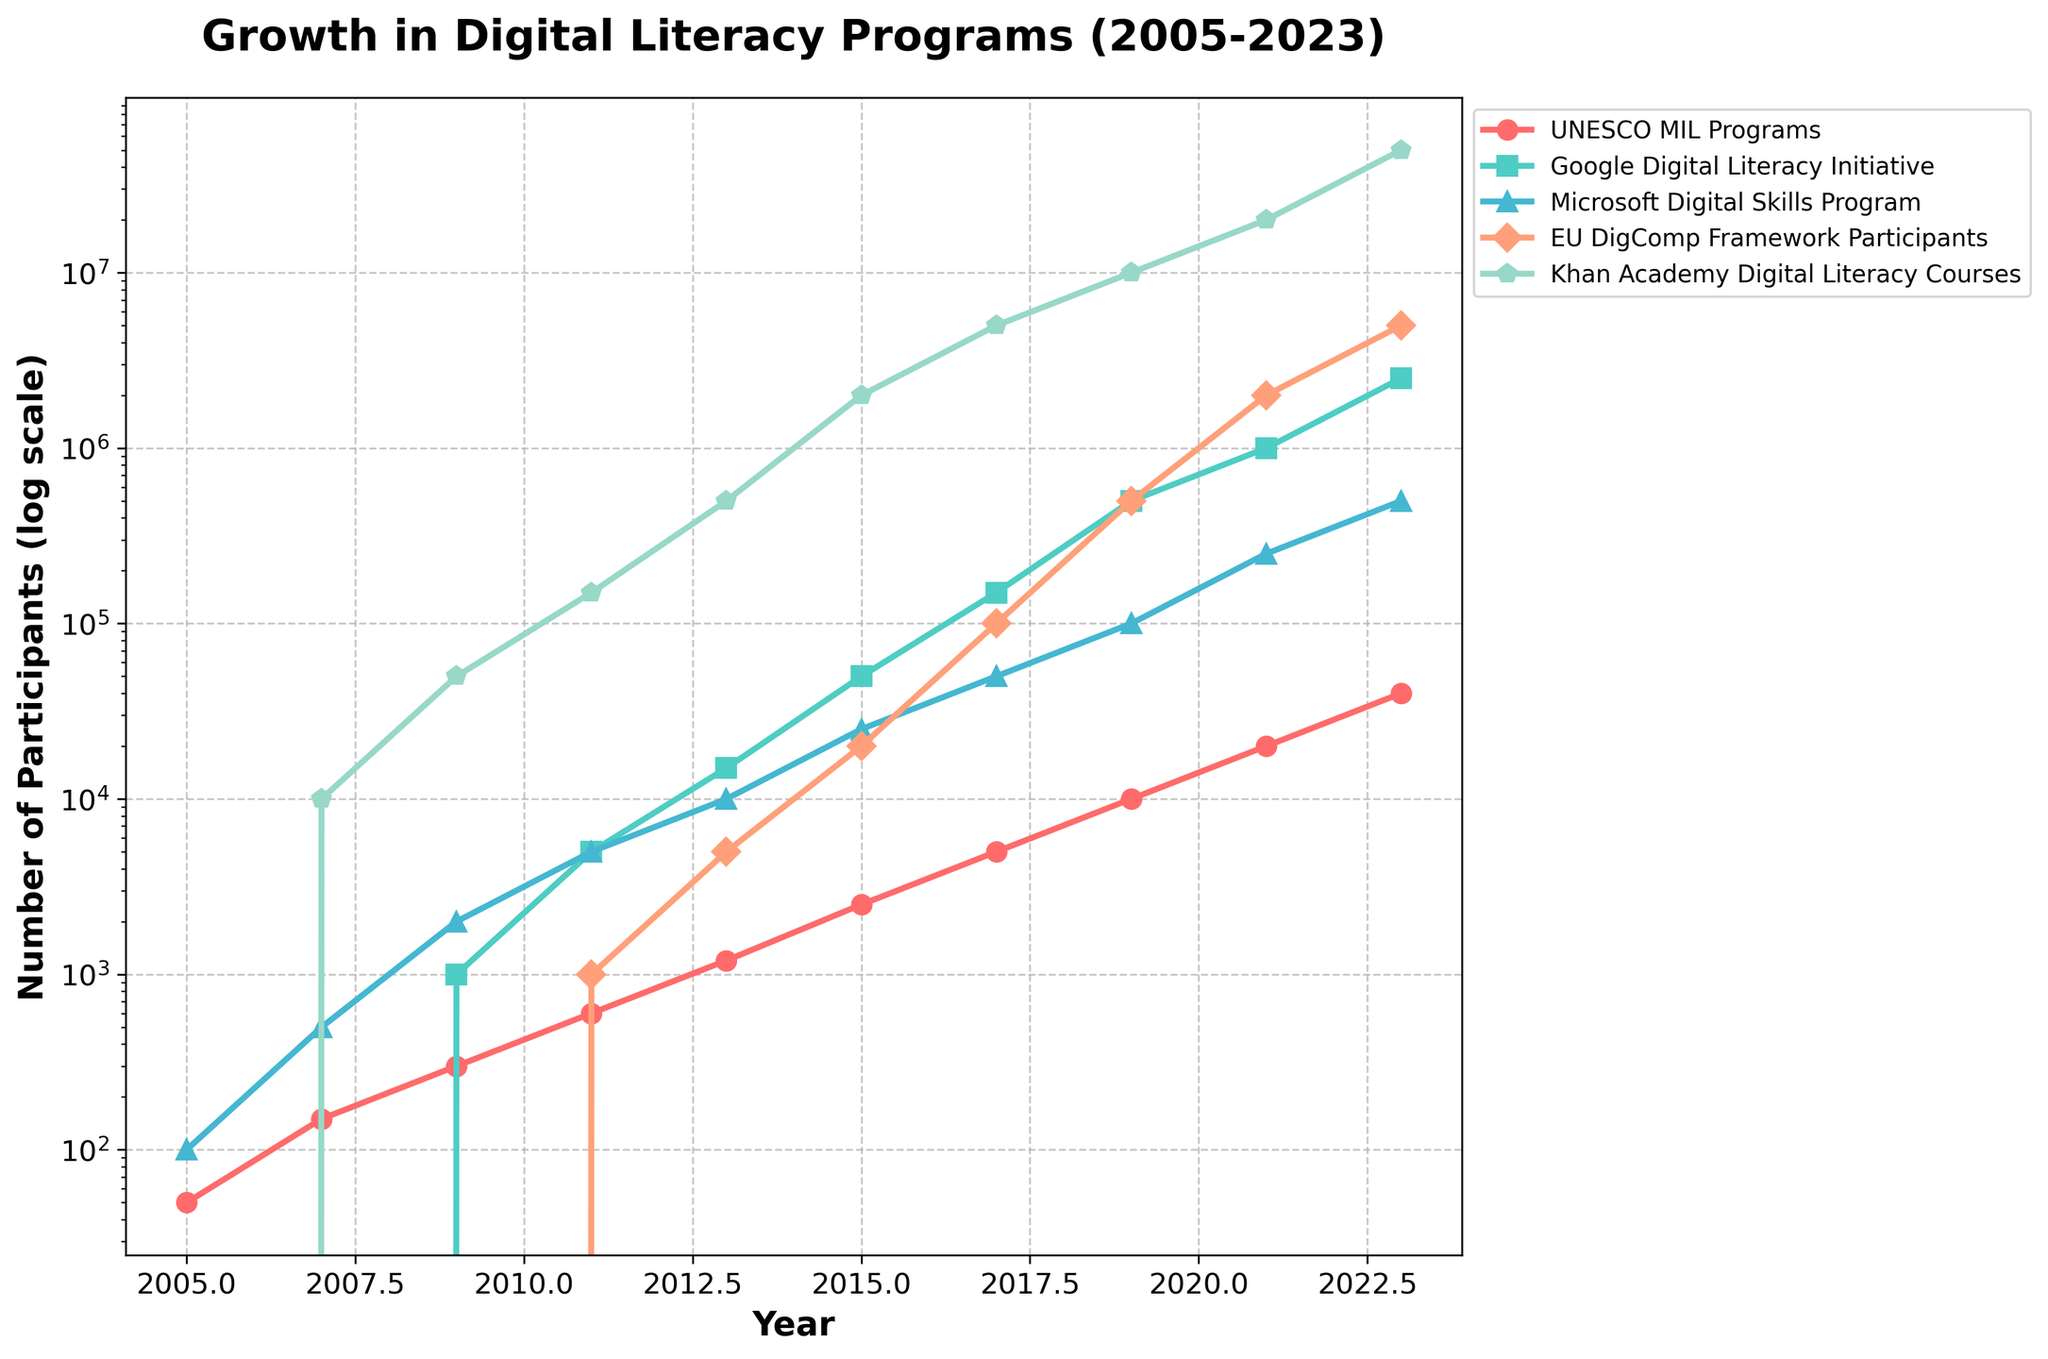What is the trend of the UNESCO MIL Programs from 2005 to 2023? The trend shows a steady increase. From 50 participants in 2005, it consistently grows to 40,000 participants by 2023. The growth pattern accelerates particularly after 2009.
Answer: Steady increase How do the participants in the Khan Academy Digital Literacy Courses compare between 2011 and 2023? In 2011, there were 150,000 participants, and by 2023, there are 50,000,000 participants. To compare, 50,000,000 - 150,000 = 49,850,000 more participants in 2023.
Answer: 49,850,000 more in 2023 Which digital literacy program had the most significant increase in participants between 2019 and 2021? Google's Digital Literacy Initiative grew from 500,000 to 1,000,000 participants, a 500,000 increase. Comparing this to other programs in the same period, none comes close to this increase.
Answer: Google Digital Literacy Initiative Among the five programs, which had the least number of participants in 2009? In 2009, the programs had the following participants: UNESCO MIL (300), Google (1,000), Microsoft (2,000), EU DigComp (0), Khan Academy (50,000). The EU DigComp Framework had 0 participants.
Answer: EU DigComp Framework Calculate the total number of participants in all programs in 2021. Summing the participants in 2021 from all programs: UNESCO MIL (20,000), Google (1,000,000), Microsoft (250,000), EU DigComp (2,000,000), Khan Academy (20,000,000). Total: 20,000 + 1,000,000 + 250,000 + 2,000,000 + 20,000,000 = 23,270,000.
Answer: 23,270,000 Which program had a participation count closest to 500,000 in 2023? In 2023, the participation counts are: UNESCO MIL (40,000), Google (2,500,000), Microsoft (500,000), EU DigComp (5,000,000), Khan Academy (50,000,000). The closest program is the Microsoft Digital Skills Program with exactly 500,000 participants.
Answer: Microsoft Digital Skills Program What is the difference in participant count between Microsoft Digital Skills Program and EU DigComp Framework Participants in 2015? In 2015, Microsoft had 25,000 participants, and EU DigComp had 20,000 participants. Difference: 25,000 - 20,000 = 5,000 participants.
Answer: 5,000 Which color is used to represent Khan Academy Digital Literacy Courses on the chart? The Khan Academy Digital Literacy Courses are represented by the green-colored line on the chart.
Answer: Green 